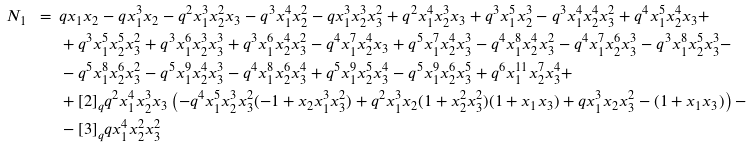<formula> <loc_0><loc_0><loc_500><loc_500>N _ { 1 } \ = \ & q x _ { 1 } x _ { 2 } - q x _ { 1 } ^ { 3 } x _ { 2 } - q ^ { 2 } x _ { 1 } ^ { 3 } x _ { 2 } ^ { 2 } x _ { 3 } - q ^ { 3 } x _ { 1 } ^ { 4 } x _ { 2 } ^ { 2 } - q x _ { 1 } ^ { 3 } x _ { 2 } ^ { 3 } x _ { 3 } ^ { 2 } + q ^ { 2 } x _ { 1 } ^ { 4 } x _ { 2 } ^ { 3 } x _ { 3 } + q ^ { 3 } x _ { 1 } ^ { 5 } x _ { 2 } ^ { 3 } - q ^ { 3 } x _ { 1 } ^ { 4 } x _ { 2 } ^ { 4 } x _ { 3 } ^ { 2 } + q ^ { 4 } x _ { 1 } ^ { 5 } x _ { 2 } ^ { 4 } x _ { 3 } + \\ & + q ^ { 3 } x _ { 1 } ^ { 5 } x _ { 2 } ^ { 5 } x _ { 3 } ^ { 2 } + q ^ { 3 } x _ { 1 } ^ { 6 } x _ { 2 } ^ { 3 } x _ { 3 } ^ { 3 } + q ^ { 3 } x _ { 1 } ^ { 6 } x _ { 2 } ^ { 4 } x _ { 3 } ^ { 2 } - q ^ { 4 } x _ { 1 } ^ { 7 } x _ { 2 } ^ { 4 } x _ { 3 } + q ^ { 5 } x _ { 1 } ^ { 7 } x _ { 2 } ^ { 4 } x _ { 3 } ^ { 3 } - q ^ { 4 } x _ { 1 } ^ { 8 } x _ { 2 } ^ { 4 } x _ { 3 } ^ { 2 } - q ^ { 4 } x _ { 1 } ^ { 7 } x _ { 2 } ^ { 6 } x _ { 3 } ^ { 3 } - q ^ { 3 } x _ { 1 } ^ { 8 } x _ { 2 } ^ { 5 } x _ { 3 } ^ { 3 } - \\ & - q ^ { 5 } x _ { 1 } ^ { 8 } x _ { 2 } ^ { 6 } x _ { 3 } ^ { 2 } - q ^ { 5 } x _ { 1 } ^ { 9 } x _ { 2 } ^ { 4 } x _ { 3 } ^ { 3 } - q ^ { 4 } x _ { 1 } ^ { 8 } x _ { 2 } ^ { 6 } x _ { 3 } ^ { 4 } + q ^ { 5 } x _ { 1 } ^ { 9 } x _ { 2 } ^ { 5 } x _ { 3 } ^ { 4 } - q ^ { 5 } x _ { 1 } ^ { 9 } x _ { 2 } ^ { 6 } x _ { 3 } ^ { 5 } + q ^ { 6 } x _ { 1 } ^ { 1 1 } x _ { 2 } ^ { 7 } x _ { 3 } ^ { 4 } + \\ & + [ 2 ] _ { q } q ^ { 2 } x _ { 1 } ^ { 4 } x _ { 2 } ^ { 3 } x _ { 3 } \left ( - q ^ { 4 } x _ { 1 } ^ { 5 } x _ { 2 } ^ { 3 } x _ { 3 } ^ { 2 } ( - 1 + x _ { 2 } x _ { 1 } ^ { 3 } x _ { 3 } ^ { 2 } ) + q ^ { 2 } x _ { 1 } ^ { 3 } x _ { 2 } ( 1 + x _ { 2 } ^ { 2 } x _ { 3 } ^ { 2 } ) ( 1 + x _ { 1 } x _ { 3 } ) + q x _ { 1 } ^ { 3 } x _ { 2 } x _ { 3 } ^ { 2 } - ( 1 + x _ { 1 } x _ { 3 } ) \right ) - \\ & - [ 3 ] _ { q } q x _ { 1 } ^ { 4 } x _ { 2 } ^ { 2 } x _ { 3 } ^ { 2 }</formula> 